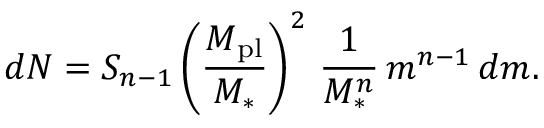Convert formula to latex. <formula><loc_0><loc_0><loc_500><loc_500>d N = S _ { n - 1 } \left ( \frac { M _ { p l } } { M _ { * } } \right ) ^ { 2 } \, \frac { 1 } { M _ { * } ^ { n } } \, m ^ { n - 1 } \, d m .</formula> 